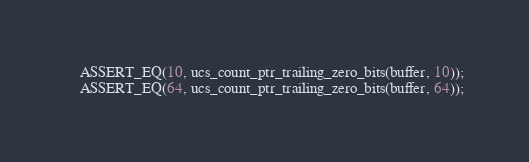Convert code to text. <code><loc_0><loc_0><loc_500><loc_500><_C++_>    ASSERT_EQ(10, ucs_count_ptr_trailing_zero_bits(buffer, 10));
    ASSERT_EQ(64, ucs_count_ptr_trailing_zero_bits(buffer, 64));</code> 